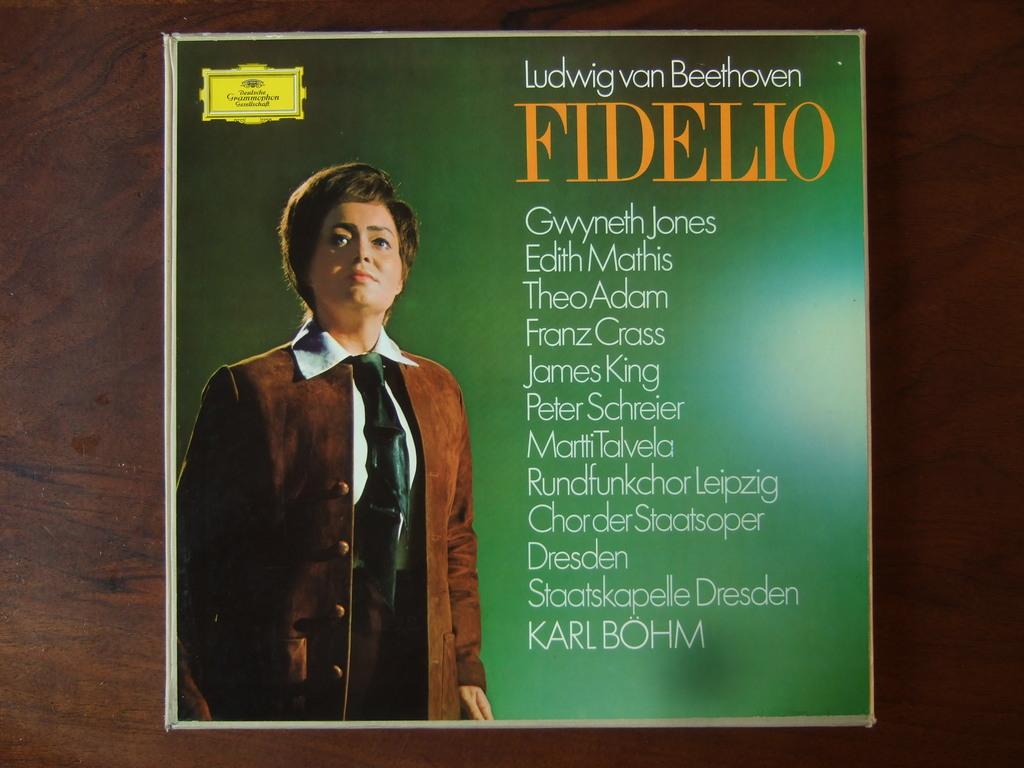What is the name in white letters above the yellow letters?
Provide a succinct answer. Ludwig van beethoven. What is the yellow text?
Your answer should be compact. Fidelio. 